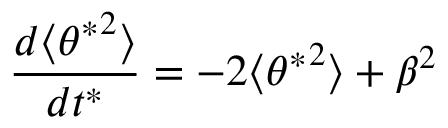Convert formula to latex. <formula><loc_0><loc_0><loc_500><loc_500>\frac { d \langle { \theta ^ { * } } ^ { 2 } \rangle } { d t ^ { * } } = - 2 \langle { \theta ^ { * } } ^ { 2 } \rangle + \beta ^ { 2 }</formula> 